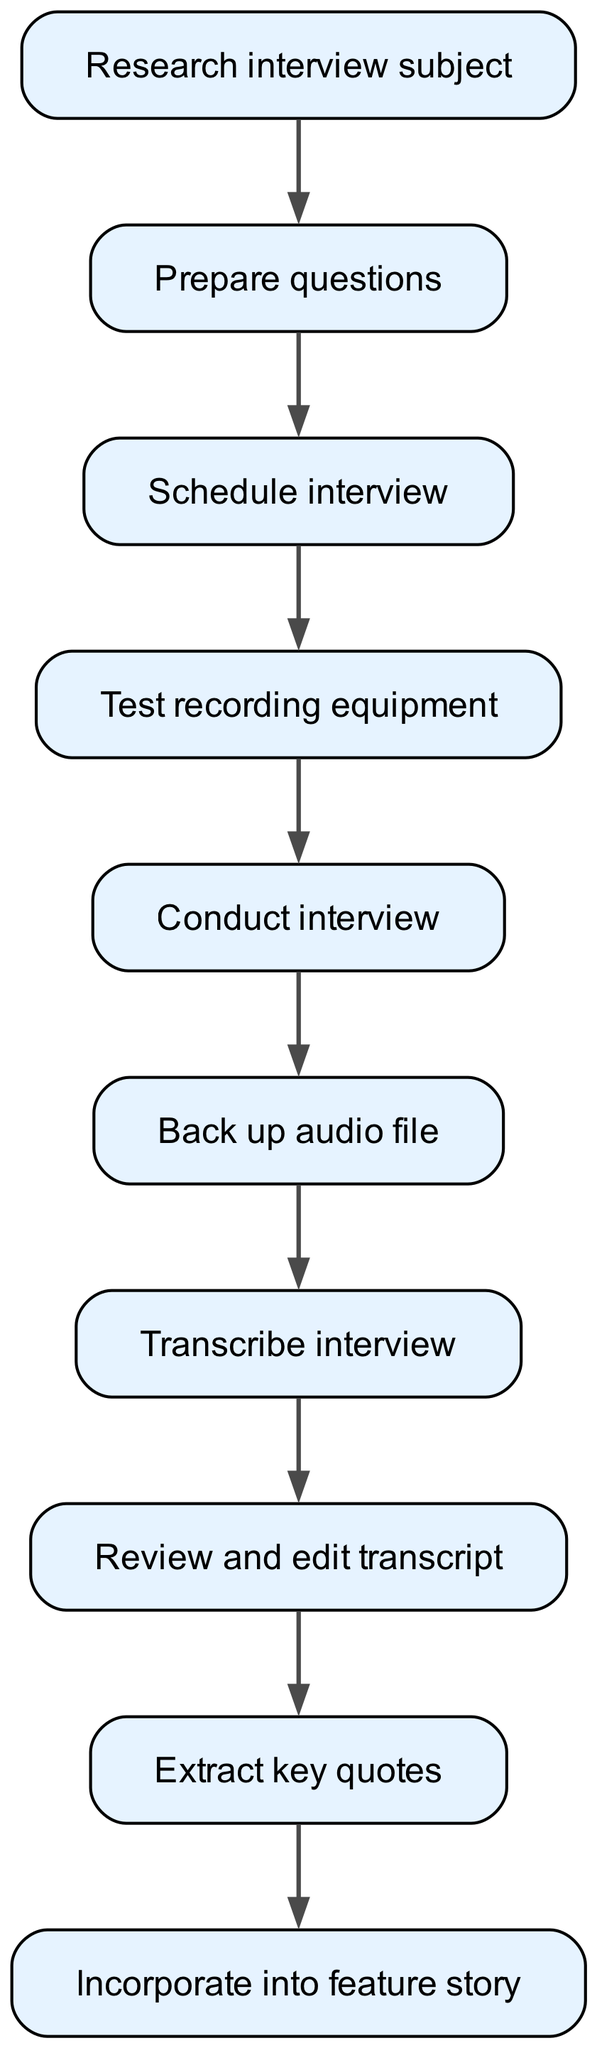What is the first step in the interview process? The first step in the diagram is "Research interview subject," which is indicated as the initial node.
Answer: Research interview subject How many elements are in the diagram? By counting the number of nodes listed in the elements, there are a total of 10 elements present in the diagram.
Answer: 10 What is the last step after transcribing the interview? The last step indicated in the flow chart is "Incorporate into feature story," which follows the transcription process.
Answer: Incorporate into feature story Which step follows "Conduct interview"? The step that directly follows "Conduct interview" is "Back up audio file," as indicated by the arrow connecting these two nodes in the flow chart.
Answer: Back up audio file What are the first three steps of the process? The first three steps indicated in the flow chart are "Research interview subject," "Prepare questions," and "Schedule interview," as they appear sequentially at the beginning of the process.
Answer: Research interview subject, Prepare questions, Schedule interview What relationship exists between "Review and edit transcript" and "Extract key quotes"? "Review and edit transcript" is directly connected to "Extract key quotes" as it follows it in the flow of the diagram, indicating that key quotes are extracted after the transcript has been reviewed and edited.
Answer: Sequential relationship What is the step immediately before "Transcribe interview"? The step immediately preceding "Transcribe interview" is "Back up audio file," showing that backing up the audio is done before transcription begins.
Answer: Back up audio file Is there any step that has more than one outgoing edge? No, each step in the diagram has a single outgoing edge, leading to the next step in the process without branching out.
Answer: No 